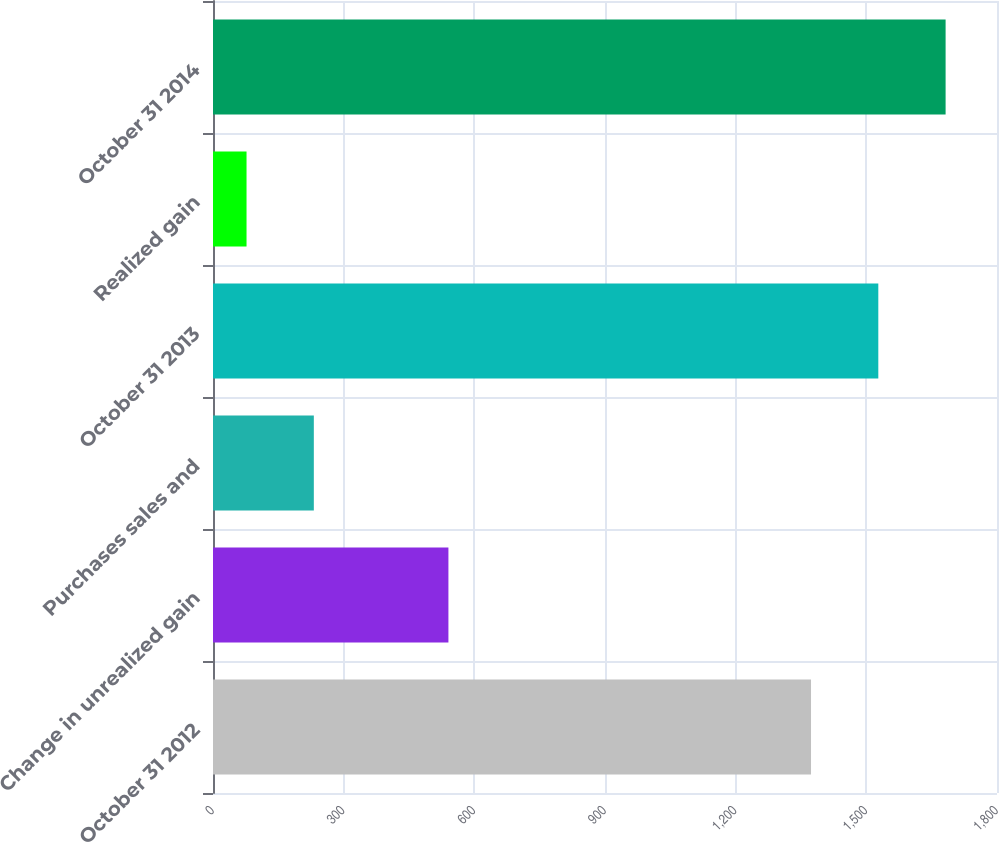Convert chart. <chart><loc_0><loc_0><loc_500><loc_500><bar_chart><fcel>October 31 2012<fcel>Change in unrealized gain<fcel>Purchases sales and<fcel>October 31 2013<fcel>Realized gain<fcel>October 31 2014<nl><fcel>1373<fcel>540.5<fcel>231.5<fcel>1527.5<fcel>77<fcel>1682<nl></chart> 